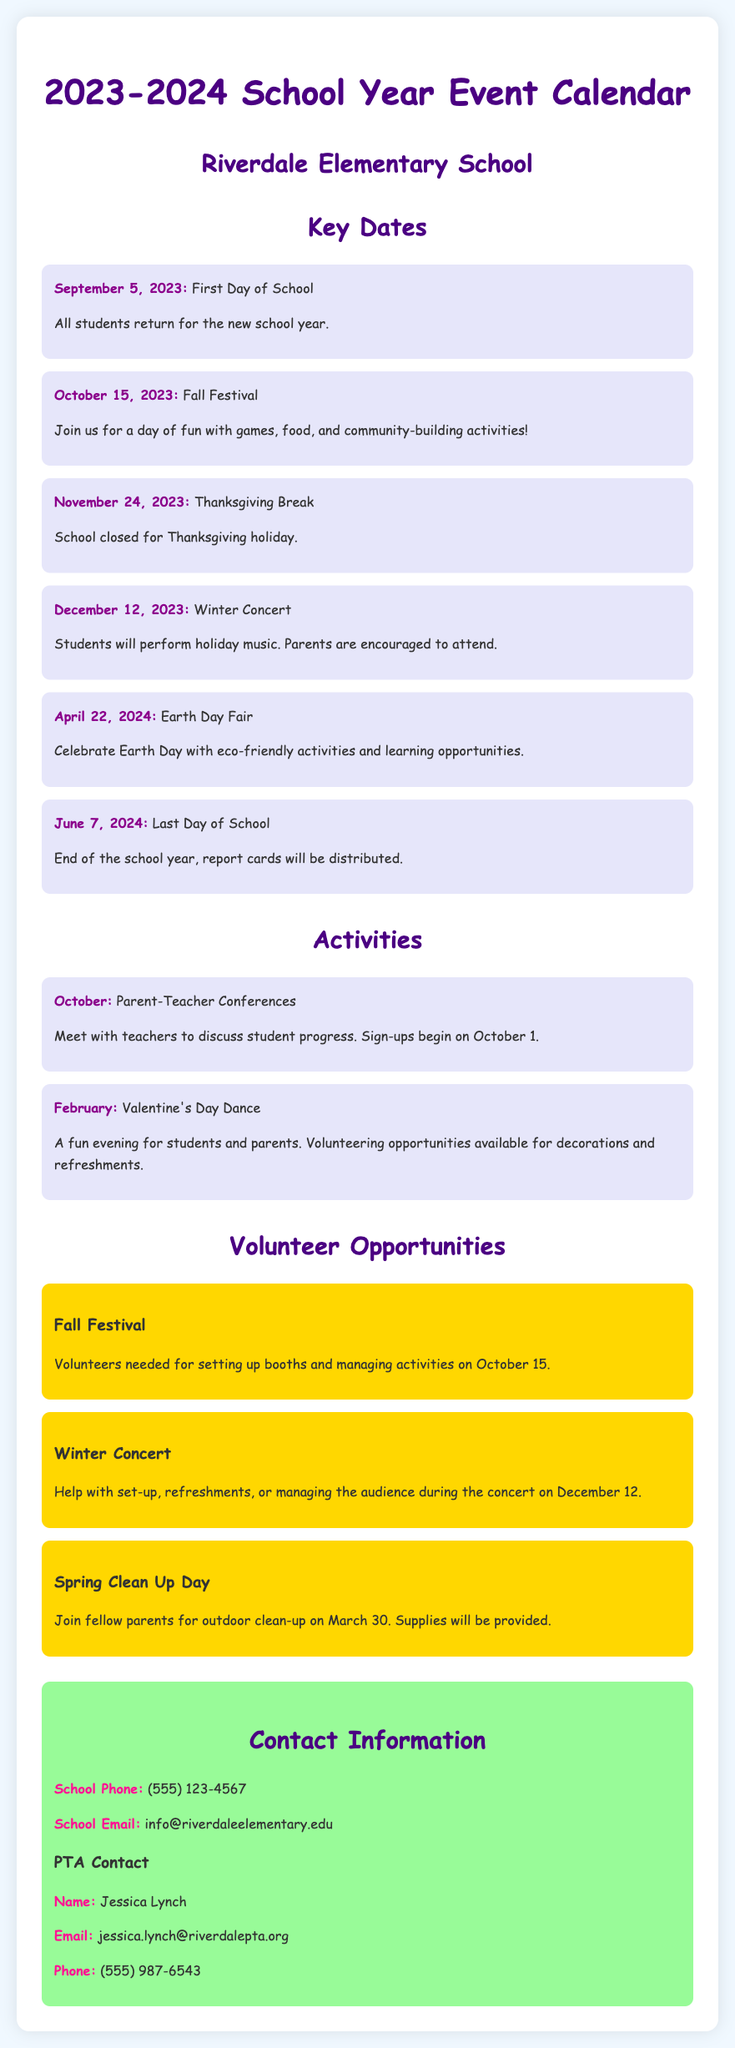What is the first day of school? The first day of school is a specific date mentioned in the event calendar.
Answer: September 5, 2023 What event takes place on October 15, 2023? This question refers to a specific event listed in the calendar for that date.
Answer: Fall Festival When is Thanksgiving Break scheduled? The date for Thanksgiving Break is clearly stated in the event list.
Answer: November 24, 2023 What date is the Winter Concert? The Winter Concert is an important event mentioned in the document.
Answer: December 12, 2023 What kind of opportunities are available for the Fall Festival? This question looks for specific volunteer opportunities related to the event.
Answer: Volunteers needed for setting up booths and managing activities Which month has the Valentine's Day Dance? The month for the Valentine's Day Dance can be found in the activities section.
Answer: February Who is the PTA contact person? This question seeks the name of a specific contact provided in the contact information section.
Answer: Jessica Lynch What is the school email address? The school email is listed in the contact information section of the document.
Answer: info@riverdaleelementary.edu How many volunteer opportunities are mentioned? This question requires counting the number of specific volunteer opportunities listed.
Answer: Three 